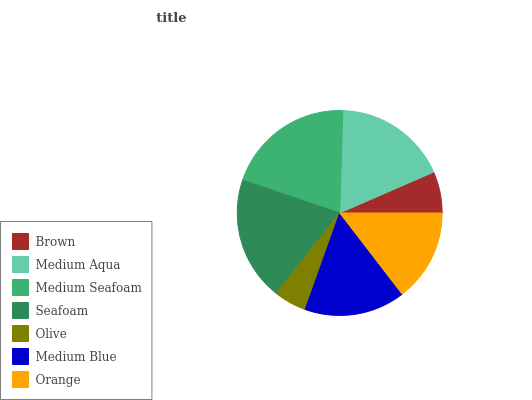Is Olive the minimum?
Answer yes or no. Yes. Is Medium Seafoam the maximum?
Answer yes or no. Yes. Is Medium Aqua the minimum?
Answer yes or no. No. Is Medium Aqua the maximum?
Answer yes or no. No. Is Medium Aqua greater than Brown?
Answer yes or no. Yes. Is Brown less than Medium Aqua?
Answer yes or no. Yes. Is Brown greater than Medium Aqua?
Answer yes or no. No. Is Medium Aqua less than Brown?
Answer yes or no. No. Is Medium Blue the high median?
Answer yes or no. Yes. Is Medium Blue the low median?
Answer yes or no. Yes. Is Seafoam the high median?
Answer yes or no. No. Is Seafoam the low median?
Answer yes or no. No. 